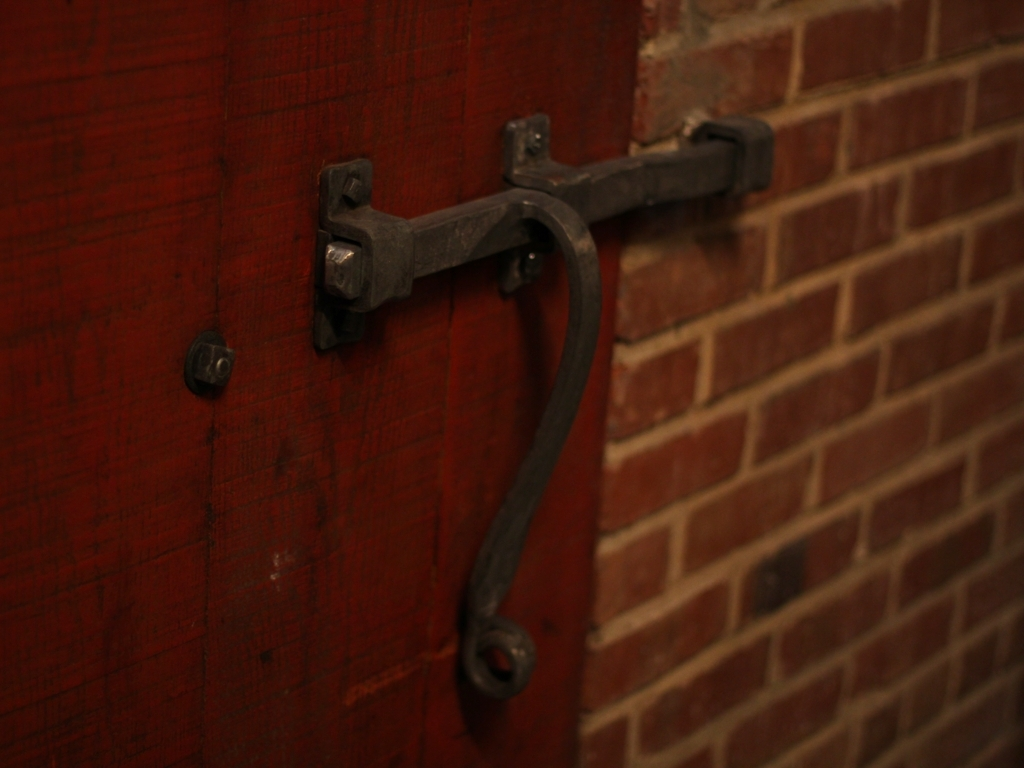What historical period might the latch design suggest, and are there any other objects that corroborate that era? The latch design has a rustic, hand-forged appearance, hinting at a late 19th to early 20th-century period. The heavy use of iron and the simple, utilitarian design are characteristic of industrial era craftsmanship. There's a visible brick wall which complements the latch, as exposed brickwork became a popular architectural feature around the same time, supporting the historical context. 